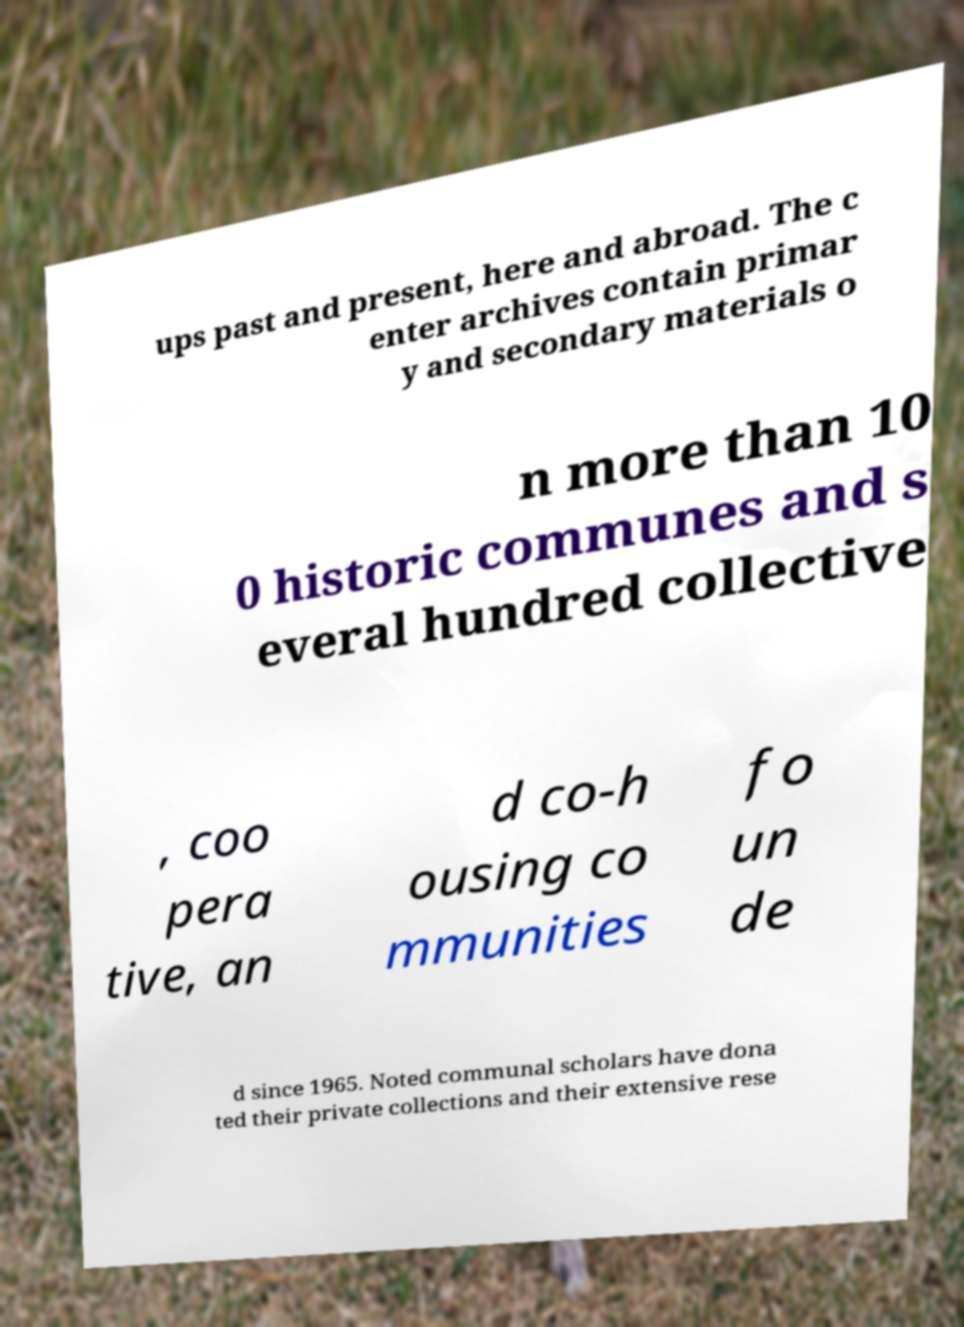Can you accurately transcribe the text from the provided image for me? ups past and present, here and abroad. The c enter archives contain primar y and secondary materials o n more than 10 0 historic communes and s everal hundred collective , coo pera tive, an d co-h ousing co mmunities fo un de d since 1965. Noted communal scholars have dona ted their private collections and their extensive rese 